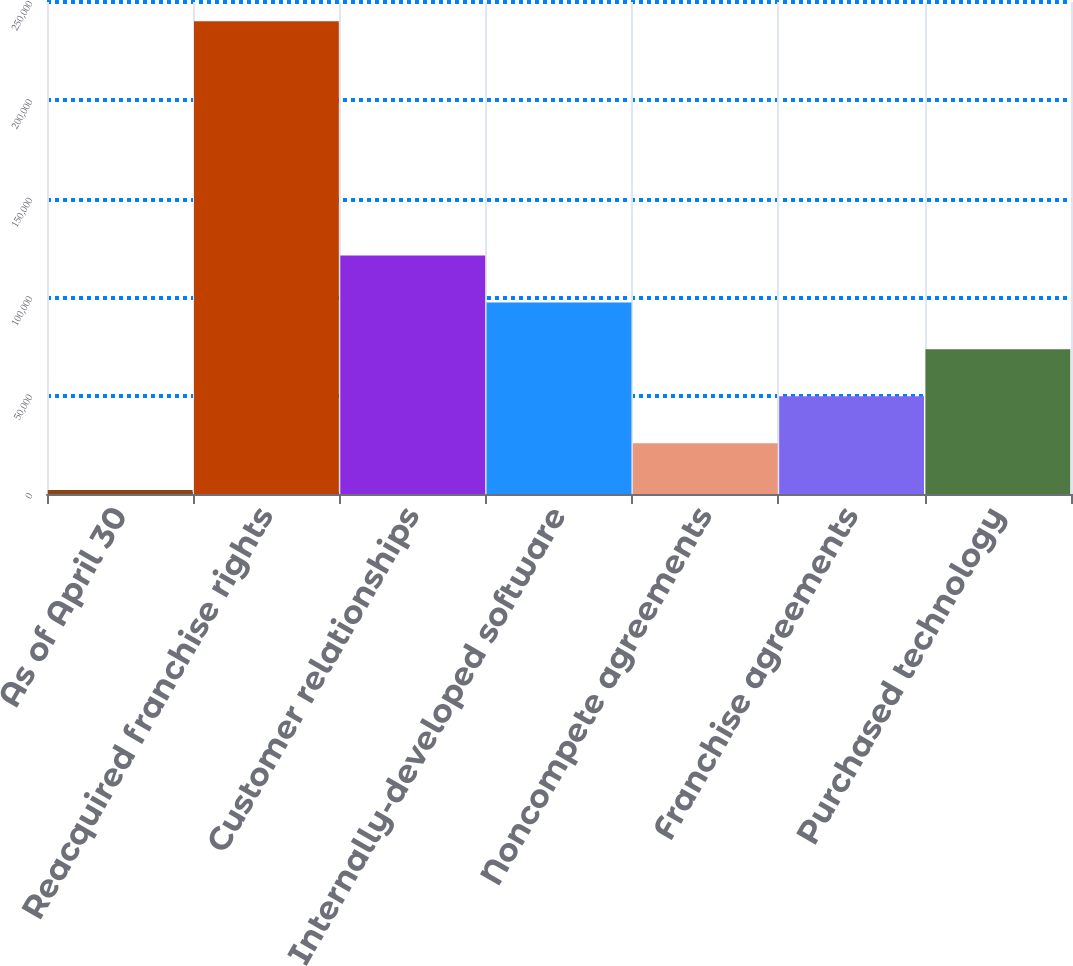<chart> <loc_0><loc_0><loc_500><loc_500><bar_chart><fcel>As of April 30<fcel>Reacquired franchise rights<fcel>Customer relationships<fcel>Internally-developed software<fcel>Noncompete agreements<fcel>Franchise agreements<fcel>Purchased technology<nl><fcel>2017<fcel>240273<fcel>121145<fcel>97319.4<fcel>25842.6<fcel>49668.2<fcel>73493.8<nl></chart> 